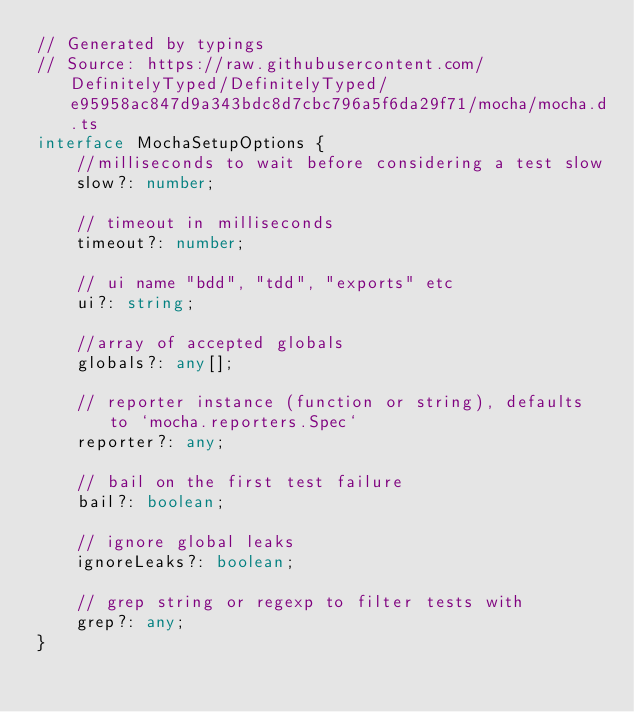Convert code to text. <code><loc_0><loc_0><loc_500><loc_500><_TypeScript_>// Generated by typings
// Source: https://raw.githubusercontent.com/DefinitelyTyped/DefinitelyTyped/e95958ac847d9a343bdc8d7cbc796a5f6da29f71/mocha/mocha.d.ts
interface MochaSetupOptions {
    //milliseconds to wait before considering a test slow
    slow?: number;

    // timeout in milliseconds
    timeout?: number;

    // ui name "bdd", "tdd", "exports" etc
    ui?: string;

    //array of accepted globals
    globals?: any[];

    // reporter instance (function or string), defaults to `mocha.reporters.Spec`
    reporter?: any;

    // bail on the first test failure
    bail?: boolean;

    // ignore global leaks
    ignoreLeaks?: boolean;

    // grep string or regexp to filter tests with
    grep?: any;
}
</code> 